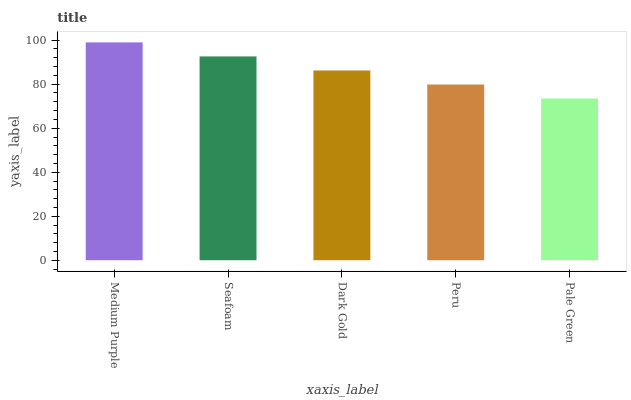Is Pale Green the minimum?
Answer yes or no. Yes. Is Medium Purple the maximum?
Answer yes or no. Yes. Is Seafoam the minimum?
Answer yes or no. No. Is Seafoam the maximum?
Answer yes or no. No. Is Medium Purple greater than Seafoam?
Answer yes or no. Yes. Is Seafoam less than Medium Purple?
Answer yes or no. Yes. Is Seafoam greater than Medium Purple?
Answer yes or no. No. Is Medium Purple less than Seafoam?
Answer yes or no. No. Is Dark Gold the high median?
Answer yes or no. Yes. Is Dark Gold the low median?
Answer yes or no. Yes. Is Peru the high median?
Answer yes or no. No. Is Peru the low median?
Answer yes or no. No. 